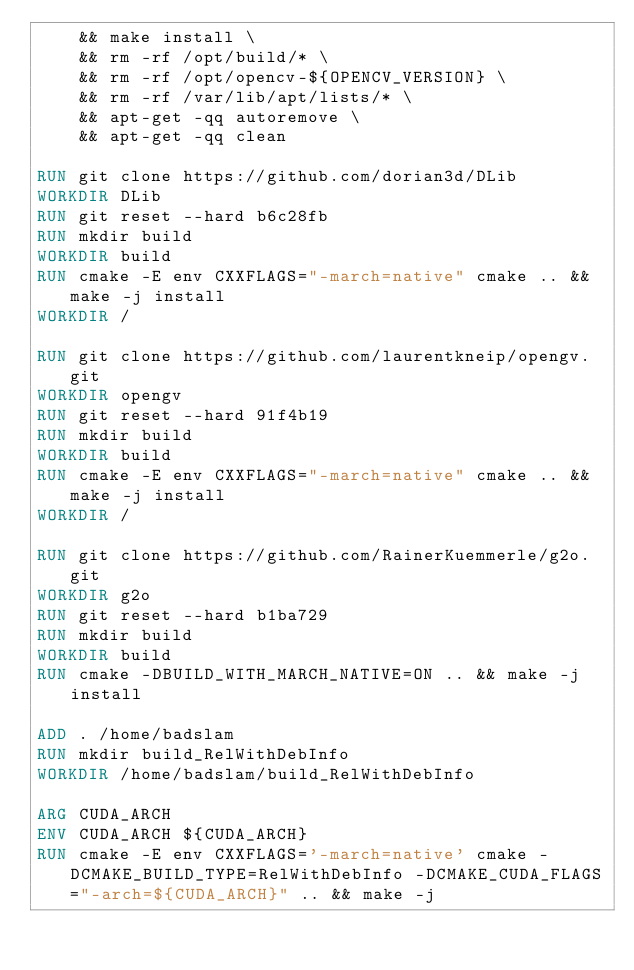<code> <loc_0><loc_0><loc_500><loc_500><_Dockerfile_>    && make install \
    && rm -rf /opt/build/* \
    && rm -rf /opt/opencv-${OPENCV_VERSION} \
    && rm -rf /var/lib/apt/lists/* \
    && apt-get -qq autoremove \
    && apt-get -qq clean

RUN git clone https://github.com/dorian3d/DLib
WORKDIR DLib
RUN git reset --hard b6c28fb
RUN mkdir build
WORKDIR build
RUN cmake -E env CXXFLAGS="-march=native" cmake .. && make -j install
WORKDIR /

RUN git clone https://github.com/laurentkneip/opengv.git
WORKDIR opengv
RUN git reset --hard 91f4b19
RUN mkdir build
WORKDIR build
RUN cmake -E env CXXFLAGS="-march=native" cmake .. && make -j install
WORKDIR /

RUN git clone https://github.com/RainerKuemmerle/g2o.git
WORKDIR g2o
RUN git reset --hard b1ba729
RUN mkdir build
WORKDIR build
RUN cmake -DBUILD_WITH_MARCH_NATIVE=ON .. && make -j install

ADD . /home/badslam
RUN mkdir build_RelWithDebInfo
WORKDIR /home/badslam/build_RelWithDebInfo

ARG CUDA_ARCH
ENV CUDA_ARCH ${CUDA_ARCH}
RUN cmake -E env CXXFLAGS='-march=native' cmake -DCMAKE_BUILD_TYPE=RelWithDebInfo -DCMAKE_CUDA_FLAGS="-arch=${CUDA_ARCH}" .. && make -j
</code> 